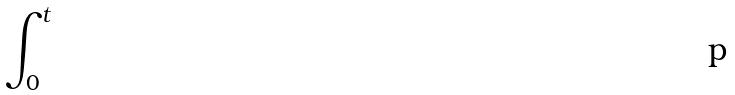Convert formula to latex. <formula><loc_0><loc_0><loc_500><loc_500>\int _ { 0 } ^ { t }</formula> 